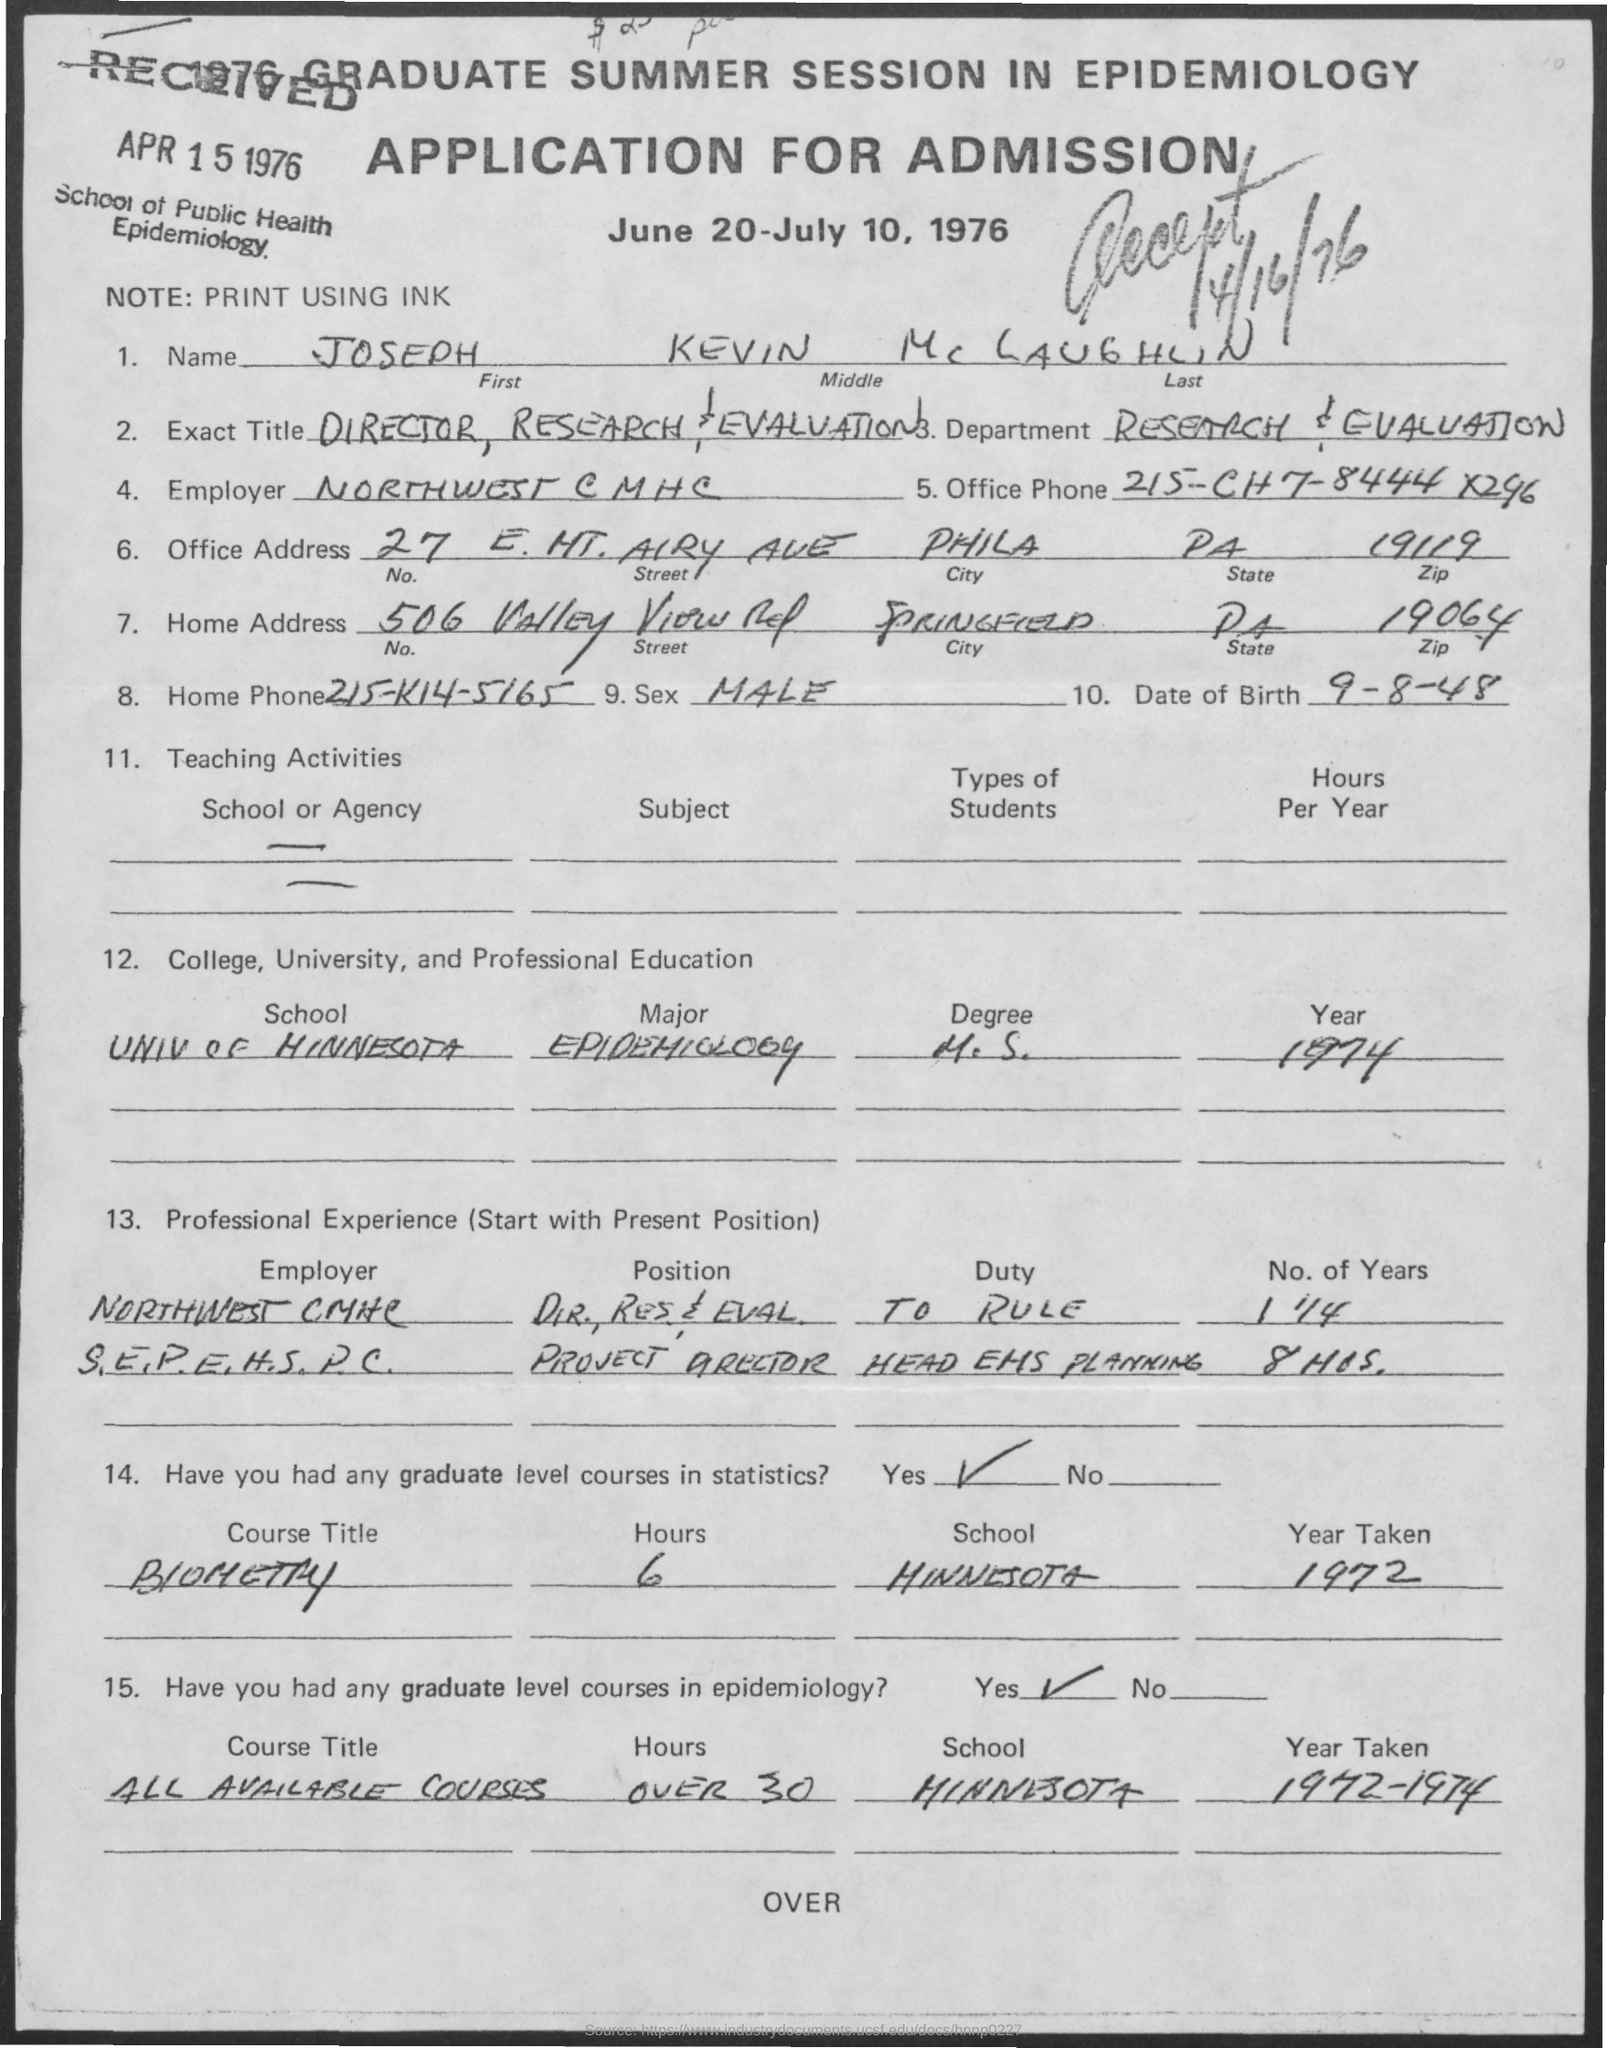Specify some key components in this picture. The name "Joseph" is mentioned in the given application. What is the ZIP code for the office address mentioned in the given application? The ZIP code is 19119. The date on which the application was received is April 15, 1976. The sex mentioned in the given application is male. The date of birth mentioned in the given application is September 8, 1948. 